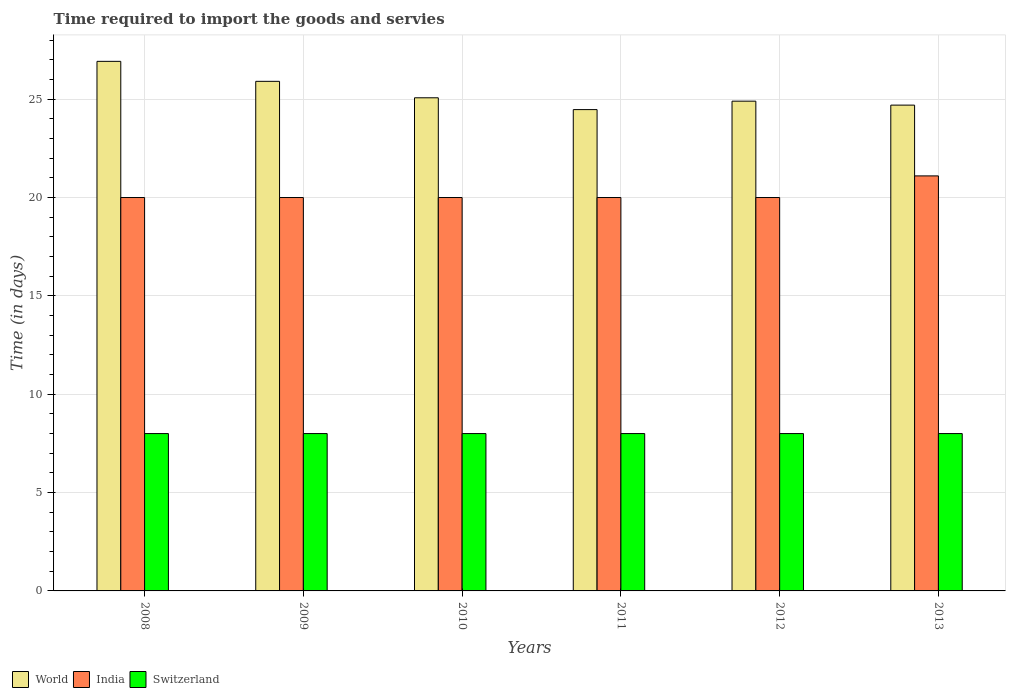How many groups of bars are there?
Provide a succinct answer. 6. Are the number of bars per tick equal to the number of legend labels?
Offer a terse response. Yes. Are the number of bars on each tick of the X-axis equal?
Provide a succinct answer. Yes. In how many cases, is the number of bars for a given year not equal to the number of legend labels?
Offer a terse response. 0. What is the number of days required to import the goods and services in World in 2009?
Make the answer very short. 25.91. Across all years, what is the maximum number of days required to import the goods and services in Switzerland?
Offer a terse response. 8. Across all years, what is the minimum number of days required to import the goods and services in World?
Offer a very short reply. 24.47. In which year was the number of days required to import the goods and services in World maximum?
Keep it short and to the point. 2008. What is the total number of days required to import the goods and services in India in the graph?
Provide a succinct answer. 121.1. What is the difference between the number of days required to import the goods and services in World in 2009 and that in 2011?
Make the answer very short. 1.44. What is the difference between the number of days required to import the goods and services in India in 2012 and the number of days required to import the goods and services in World in 2013?
Offer a very short reply. -4.7. What is the average number of days required to import the goods and services in World per year?
Make the answer very short. 25.33. What is the ratio of the number of days required to import the goods and services in World in 2010 to that in 2011?
Provide a short and direct response. 1.02. Is the difference between the number of days required to import the goods and services in Switzerland in 2008 and 2011 greater than the difference between the number of days required to import the goods and services in India in 2008 and 2011?
Make the answer very short. No. What is the difference between the highest and the second highest number of days required to import the goods and services in World?
Your response must be concise. 1.02. What is the difference between the highest and the lowest number of days required to import the goods and services in India?
Provide a succinct answer. 1.1. In how many years, is the number of days required to import the goods and services in India greater than the average number of days required to import the goods and services in India taken over all years?
Your answer should be very brief. 1. What does the 3rd bar from the left in 2009 represents?
Your answer should be compact. Switzerland. What does the 2nd bar from the right in 2010 represents?
Ensure brevity in your answer.  India. Are the values on the major ticks of Y-axis written in scientific E-notation?
Your answer should be compact. No. Does the graph contain grids?
Your answer should be very brief. Yes. How many legend labels are there?
Your answer should be very brief. 3. What is the title of the graph?
Give a very brief answer. Time required to import the goods and servies. Does "Liechtenstein" appear as one of the legend labels in the graph?
Offer a very short reply. No. What is the label or title of the Y-axis?
Offer a very short reply. Time (in days). What is the Time (in days) of World in 2008?
Your answer should be compact. 26.92. What is the Time (in days) in India in 2008?
Ensure brevity in your answer.  20. What is the Time (in days) in Switzerland in 2008?
Provide a succinct answer. 8. What is the Time (in days) of World in 2009?
Provide a succinct answer. 25.91. What is the Time (in days) of India in 2009?
Keep it short and to the point. 20. What is the Time (in days) in Switzerland in 2009?
Provide a succinct answer. 8. What is the Time (in days) of World in 2010?
Ensure brevity in your answer.  25.07. What is the Time (in days) of India in 2010?
Keep it short and to the point. 20. What is the Time (in days) of World in 2011?
Provide a short and direct response. 24.47. What is the Time (in days) in Switzerland in 2011?
Your answer should be very brief. 8. What is the Time (in days) in World in 2012?
Provide a succinct answer. 24.9. What is the Time (in days) in Switzerland in 2012?
Give a very brief answer. 8. What is the Time (in days) in World in 2013?
Your response must be concise. 24.7. What is the Time (in days) in India in 2013?
Keep it short and to the point. 21.1. Across all years, what is the maximum Time (in days) in World?
Your answer should be very brief. 26.92. Across all years, what is the maximum Time (in days) of India?
Your answer should be very brief. 21.1. Across all years, what is the maximum Time (in days) of Switzerland?
Provide a succinct answer. 8. Across all years, what is the minimum Time (in days) of World?
Your answer should be very brief. 24.47. Across all years, what is the minimum Time (in days) in Switzerland?
Your answer should be very brief. 8. What is the total Time (in days) in World in the graph?
Keep it short and to the point. 151.97. What is the total Time (in days) in India in the graph?
Make the answer very short. 121.1. What is the difference between the Time (in days) of World in 2008 and that in 2009?
Your answer should be very brief. 1.02. What is the difference between the Time (in days) of India in 2008 and that in 2009?
Provide a short and direct response. 0. What is the difference between the Time (in days) in World in 2008 and that in 2010?
Your answer should be very brief. 1.85. What is the difference between the Time (in days) in India in 2008 and that in 2010?
Provide a short and direct response. 0. What is the difference between the Time (in days) in World in 2008 and that in 2011?
Give a very brief answer. 2.45. What is the difference between the Time (in days) in India in 2008 and that in 2011?
Your answer should be very brief. 0. What is the difference between the Time (in days) in Switzerland in 2008 and that in 2011?
Provide a succinct answer. 0. What is the difference between the Time (in days) in World in 2008 and that in 2012?
Offer a very short reply. 2.02. What is the difference between the Time (in days) in India in 2008 and that in 2012?
Offer a terse response. 0. What is the difference between the Time (in days) of World in 2008 and that in 2013?
Offer a terse response. 2.22. What is the difference between the Time (in days) of Switzerland in 2008 and that in 2013?
Your answer should be very brief. 0. What is the difference between the Time (in days) in World in 2009 and that in 2010?
Keep it short and to the point. 0.84. What is the difference between the Time (in days) in Switzerland in 2009 and that in 2010?
Your response must be concise. 0. What is the difference between the Time (in days) of World in 2009 and that in 2011?
Your answer should be compact. 1.44. What is the difference between the Time (in days) of India in 2009 and that in 2011?
Your answer should be very brief. 0. What is the difference between the Time (in days) in World in 2009 and that in 2012?
Keep it short and to the point. 1.01. What is the difference between the Time (in days) of Switzerland in 2009 and that in 2012?
Offer a very short reply. 0. What is the difference between the Time (in days) of World in 2009 and that in 2013?
Your answer should be compact. 1.21. What is the difference between the Time (in days) of India in 2009 and that in 2013?
Keep it short and to the point. -1.1. What is the difference between the Time (in days) of Switzerland in 2009 and that in 2013?
Keep it short and to the point. 0. What is the difference between the Time (in days) in World in 2010 and that in 2011?
Ensure brevity in your answer.  0.6. What is the difference between the Time (in days) of World in 2010 and that in 2012?
Offer a terse response. 0.17. What is the difference between the Time (in days) of World in 2010 and that in 2013?
Keep it short and to the point. 0.37. What is the difference between the Time (in days) of India in 2010 and that in 2013?
Provide a short and direct response. -1.1. What is the difference between the Time (in days) of Switzerland in 2010 and that in 2013?
Provide a succinct answer. 0. What is the difference between the Time (in days) of World in 2011 and that in 2012?
Make the answer very short. -0.43. What is the difference between the Time (in days) of India in 2011 and that in 2012?
Make the answer very short. 0. What is the difference between the Time (in days) of World in 2011 and that in 2013?
Your answer should be very brief. -0.23. What is the difference between the Time (in days) in World in 2012 and that in 2013?
Provide a succinct answer. 0.2. What is the difference between the Time (in days) of India in 2012 and that in 2013?
Your answer should be compact. -1.1. What is the difference between the Time (in days) in Switzerland in 2012 and that in 2013?
Make the answer very short. 0. What is the difference between the Time (in days) in World in 2008 and the Time (in days) in India in 2009?
Offer a very short reply. 6.92. What is the difference between the Time (in days) in World in 2008 and the Time (in days) in Switzerland in 2009?
Make the answer very short. 18.92. What is the difference between the Time (in days) of India in 2008 and the Time (in days) of Switzerland in 2009?
Your answer should be compact. 12. What is the difference between the Time (in days) in World in 2008 and the Time (in days) in India in 2010?
Offer a very short reply. 6.92. What is the difference between the Time (in days) of World in 2008 and the Time (in days) of Switzerland in 2010?
Your answer should be compact. 18.92. What is the difference between the Time (in days) of India in 2008 and the Time (in days) of Switzerland in 2010?
Your response must be concise. 12. What is the difference between the Time (in days) in World in 2008 and the Time (in days) in India in 2011?
Your answer should be compact. 6.92. What is the difference between the Time (in days) of World in 2008 and the Time (in days) of Switzerland in 2011?
Your response must be concise. 18.92. What is the difference between the Time (in days) of India in 2008 and the Time (in days) of Switzerland in 2011?
Offer a terse response. 12. What is the difference between the Time (in days) in World in 2008 and the Time (in days) in India in 2012?
Provide a short and direct response. 6.92. What is the difference between the Time (in days) in World in 2008 and the Time (in days) in Switzerland in 2012?
Offer a terse response. 18.92. What is the difference between the Time (in days) of World in 2008 and the Time (in days) of India in 2013?
Your response must be concise. 5.82. What is the difference between the Time (in days) in World in 2008 and the Time (in days) in Switzerland in 2013?
Provide a succinct answer. 18.92. What is the difference between the Time (in days) of India in 2008 and the Time (in days) of Switzerland in 2013?
Your response must be concise. 12. What is the difference between the Time (in days) of World in 2009 and the Time (in days) of India in 2010?
Your answer should be compact. 5.91. What is the difference between the Time (in days) of World in 2009 and the Time (in days) of Switzerland in 2010?
Provide a succinct answer. 17.91. What is the difference between the Time (in days) of India in 2009 and the Time (in days) of Switzerland in 2010?
Provide a short and direct response. 12. What is the difference between the Time (in days) of World in 2009 and the Time (in days) of India in 2011?
Keep it short and to the point. 5.91. What is the difference between the Time (in days) in World in 2009 and the Time (in days) in Switzerland in 2011?
Provide a succinct answer. 17.91. What is the difference between the Time (in days) in World in 2009 and the Time (in days) in India in 2012?
Provide a succinct answer. 5.91. What is the difference between the Time (in days) of World in 2009 and the Time (in days) of Switzerland in 2012?
Make the answer very short. 17.91. What is the difference between the Time (in days) in World in 2009 and the Time (in days) in India in 2013?
Offer a terse response. 4.81. What is the difference between the Time (in days) of World in 2009 and the Time (in days) of Switzerland in 2013?
Keep it short and to the point. 17.91. What is the difference between the Time (in days) of India in 2009 and the Time (in days) of Switzerland in 2013?
Keep it short and to the point. 12. What is the difference between the Time (in days) of World in 2010 and the Time (in days) of India in 2011?
Give a very brief answer. 5.07. What is the difference between the Time (in days) of World in 2010 and the Time (in days) of Switzerland in 2011?
Provide a short and direct response. 17.07. What is the difference between the Time (in days) of World in 2010 and the Time (in days) of India in 2012?
Offer a terse response. 5.07. What is the difference between the Time (in days) of World in 2010 and the Time (in days) of Switzerland in 2012?
Your answer should be compact. 17.07. What is the difference between the Time (in days) in India in 2010 and the Time (in days) in Switzerland in 2012?
Your response must be concise. 12. What is the difference between the Time (in days) in World in 2010 and the Time (in days) in India in 2013?
Provide a short and direct response. 3.97. What is the difference between the Time (in days) of World in 2010 and the Time (in days) of Switzerland in 2013?
Provide a succinct answer. 17.07. What is the difference between the Time (in days) in World in 2011 and the Time (in days) in India in 2012?
Offer a very short reply. 4.47. What is the difference between the Time (in days) of World in 2011 and the Time (in days) of Switzerland in 2012?
Provide a short and direct response. 16.47. What is the difference between the Time (in days) of India in 2011 and the Time (in days) of Switzerland in 2012?
Your answer should be very brief. 12. What is the difference between the Time (in days) in World in 2011 and the Time (in days) in India in 2013?
Offer a terse response. 3.37. What is the difference between the Time (in days) in World in 2011 and the Time (in days) in Switzerland in 2013?
Your answer should be very brief. 16.47. What is the difference between the Time (in days) of India in 2011 and the Time (in days) of Switzerland in 2013?
Provide a short and direct response. 12. What is the difference between the Time (in days) in World in 2012 and the Time (in days) in India in 2013?
Your answer should be very brief. 3.8. What is the difference between the Time (in days) in World in 2012 and the Time (in days) in Switzerland in 2013?
Give a very brief answer. 16.9. What is the average Time (in days) in World per year?
Keep it short and to the point. 25.33. What is the average Time (in days) in India per year?
Your answer should be very brief. 20.18. In the year 2008, what is the difference between the Time (in days) of World and Time (in days) of India?
Give a very brief answer. 6.92. In the year 2008, what is the difference between the Time (in days) in World and Time (in days) in Switzerland?
Ensure brevity in your answer.  18.92. In the year 2009, what is the difference between the Time (in days) of World and Time (in days) of India?
Your answer should be compact. 5.91. In the year 2009, what is the difference between the Time (in days) in World and Time (in days) in Switzerland?
Provide a succinct answer. 17.91. In the year 2010, what is the difference between the Time (in days) in World and Time (in days) in India?
Your answer should be very brief. 5.07. In the year 2010, what is the difference between the Time (in days) of World and Time (in days) of Switzerland?
Your response must be concise. 17.07. In the year 2010, what is the difference between the Time (in days) in India and Time (in days) in Switzerland?
Ensure brevity in your answer.  12. In the year 2011, what is the difference between the Time (in days) of World and Time (in days) of India?
Keep it short and to the point. 4.47. In the year 2011, what is the difference between the Time (in days) in World and Time (in days) in Switzerland?
Give a very brief answer. 16.47. In the year 2011, what is the difference between the Time (in days) of India and Time (in days) of Switzerland?
Make the answer very short. 12. In the year 2012, what is the difference between the Time (in days) in World and Time (in days) in India?
Make the answer very short. 4.9. In the year 2012, what is the difference between the Time (in days) of World and Time (in days) of Switzerland?
Your answer should be compact. 16.9. In the year 2013, what is the difference between the Time (in days) of World and Time (in days) of India?
Provide a succinct answer. 3.6. In the year 2013, what is the difference between the Time (in days) of World and Time (in days) of Switzerland?
Provide a succinct answer. 16.7. In the year 2013, what is the difference between the Time (in days) of India and Time (in days) of Switzerland?
Offer a terse response. 13.1. What is the ratio of the Time (in days) in World in 2008 to that in 2009?
Your response must be concise. 1.04. What is the ratio of the Time (in days) of India in 2008 to that in 2009?
Give a very brief answer. 1. What is the ratio of the Time (in days) in Switzerland in 2008 to that in 2009?
Give a very brief answer. 1. What is the ratio of the Time (in days) of World in 2008 to that in 2010?
Provide a succinct answer. 1.07. What is the ratio of the Time (in days) of Switzerland in 2008 to that in 2010?
Ensure brevity in your answer.  1. What is the ratio of the Time (in days) of World in 2008 to that in 2011?
Offer a terse response. 1.1. What is the ratio of the Time (in days) in India in 2008 to that in 2011?
Give a very brief answer. 1. What is the ratio of the Time (in days) in Switzerland in 2008 to that in 2011?
Make the answer very short. 1. What is the ratio of the Time (in days) in World in 2008 to that in 2012?
Make the answer very short. 1.08. What is the ratio of the Time (in days) of India in 2008 to that in 2012?
Provide a succinct answer. 1. What is the ratio of the Time (in days) of Switzerland in 2008 to that in 2012?
Make the answer very short. 1. What is the ratio of the Time (in days) in World in 2008 to that in 2013?
Offer a very short reply. 1.09. What is the ratio of the Time (in days) in India in 2008 to that in 2013?
Keep it short and to the point. 0.95. What is the ratio of the Time (in days) in Switzerland in 2008 to that in 2013?
Your answer should be compact. 1. What is the ratio of the Time (in days) of World in 2009 to that in 2010?
Provide a succinct answer. 1.03. What is the ratio of the Time (in days) of India in 2009 to that in 2010?
Your answer should be very brief. 1. What is the ratio of the Time (in days) of World in 2009 to that in 2011?
Offer a terse response. 1.06. What is the ratio of the Time (in days) in India in 2009 to that in 2011?
Your answer should be compact. 1. What is the ratio of the Time (in days) of World in 2009 to that in 2012?
Provide a short and direct response. 1.04. What is the ratio of the Time (in days) of India in 2009 to that in 2012?
Keep it short and to the point. 1. What is the ratio of the Time (in days) in World in 2009 to that in 2013?
Offer a terse response. 1.05. What is the ratio of the Time (in days) of India in 2009 to that in 2013?
Provide a succinct answer. 0.95. What is the ratio of the Time (in days) of World in 2010 to that in 2011?
Ensure brevity in your answer.  1.02. What is the ratio of the Time (in days) of India in 2010 to that in 2011?
Make the answer very short. 1. What is the ratio of the Time (in days) of World in 2010 to that in 2012?
Provide a short and direct response. 1.01. What is the ratio of the Time (in days) of World in 2010 to that in 2013?
Your response must be concise. 1.02. What is the ratio of the Time (in days) in India in 2010 to that in 2013?
Keep it short and to the point. 0.95. What is the ratio of the Time (in days) of World in 2011 to that in 2012?
Ensure brevity in your answer.  0.98. What is the ratio of the Time (in days) in Switzerland in 2011 to that in 2012?
Give a very brief answer. 1. What is the ratio of the Time (in days) in India in 2011 to that in 2013?
Offer a terse response. 0.95. What is the ratio of the Time (in days) in India in 2012 to that in 2013?
Offer a terse response. 0.95. What is the ratio of the Time (in days) in Switzerland in 2012 to that in 2013?
Keep it short and to the point. 1. What is the difference between the highest and the second highest Time (in days) in India?
Your response must be concise. 1.1. What is the difference between the highest and the lowest Time (in days) of World?
Your answer should be very brief. 2.45. What is the difference between the highest and the lowest Time (in days) of Switzerland?
Give a very brief answer. 0. 